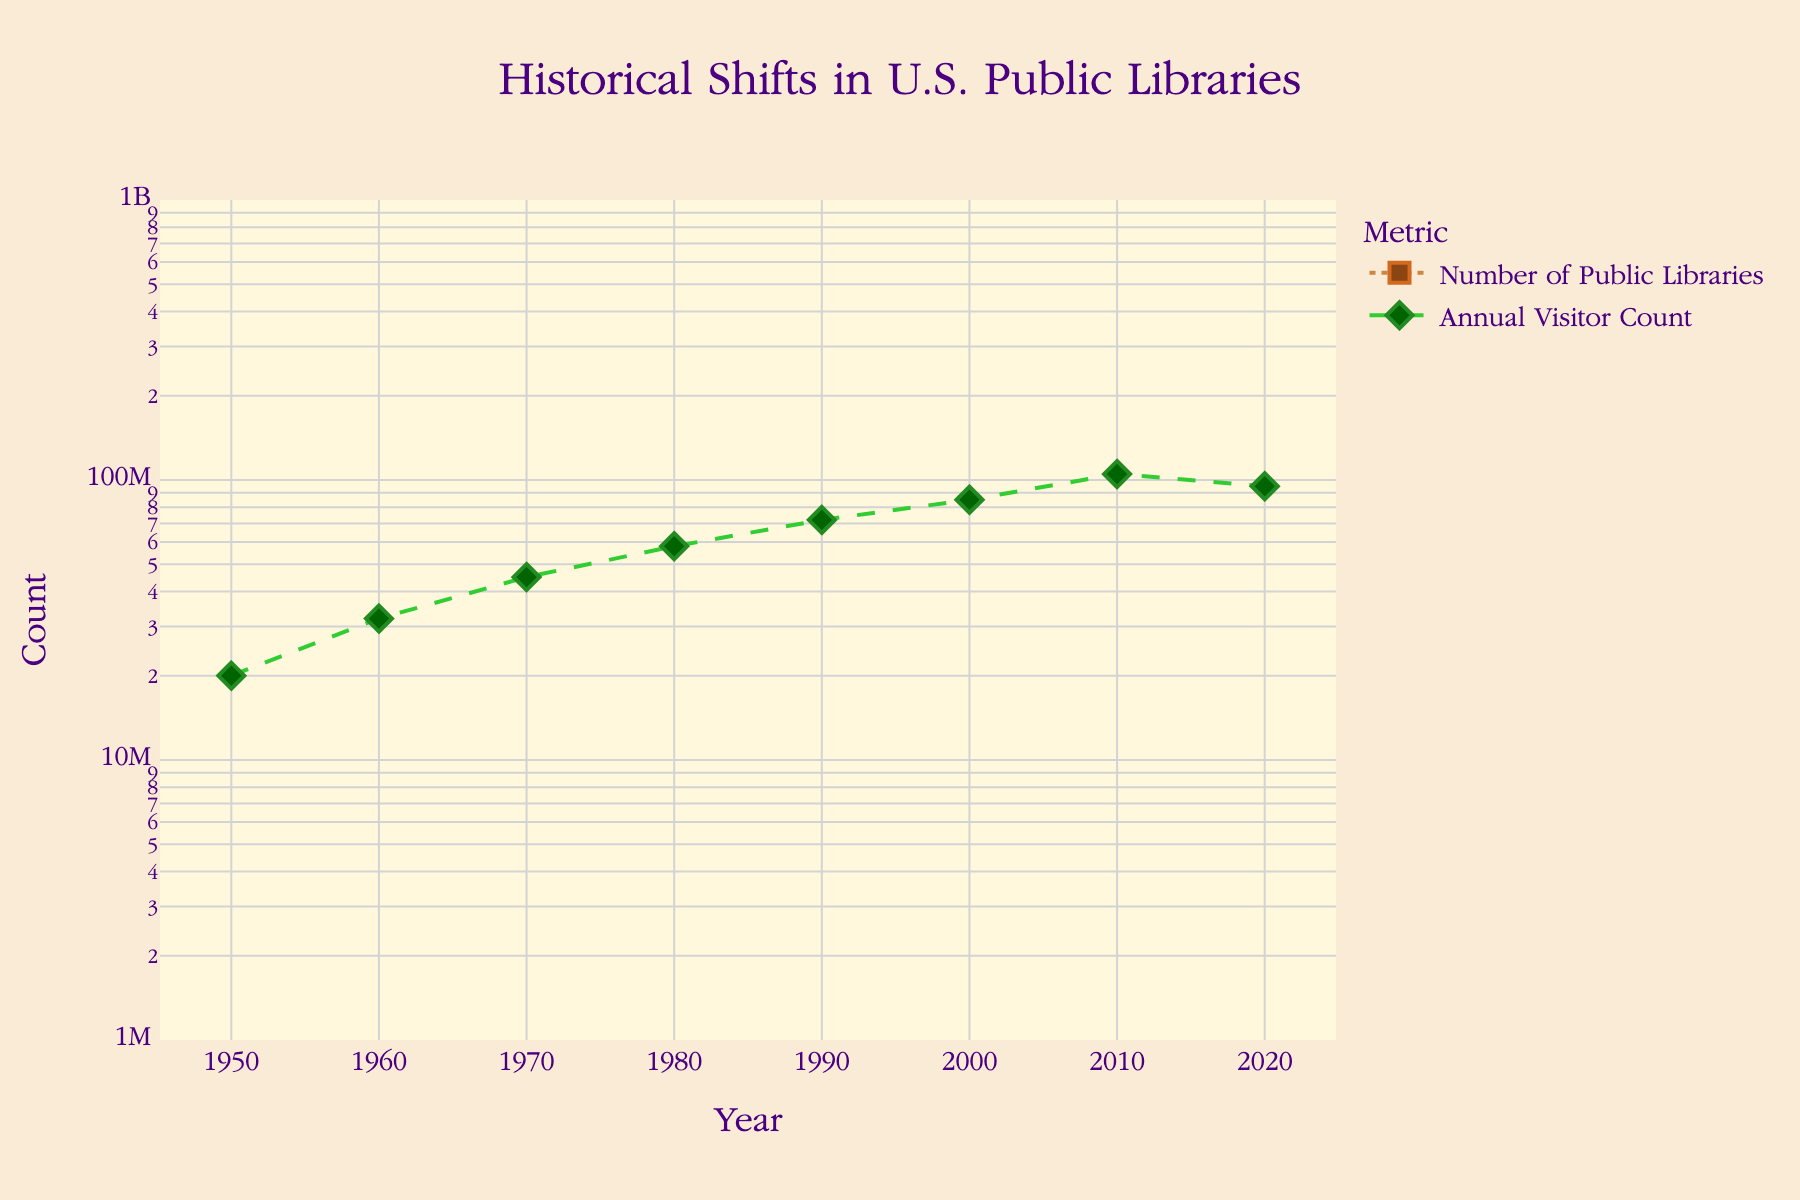what is the title of the figure? The title can be found at the top of the figure. In this case, the figure's title states the primary focus of the chart, which is "Historical Shifts in U.S. Public Libraries."
Answer: Historical Shifts in U.S. Public Libraries How many years are being displayed in the figure? Count the number of x-axis ticks labeled with years to find the number of displayed years. The years listed in the data are 1950, 1960, 1970, 1980, 1990, 2000, 2010, and 2020, thus covering a span of decades.
Answer: 8 What color represents the "Annual Visitor Count" data points? The color representing the "Annual Visitor Count" can be determined by looking at the legend of the figure. The legend shows markers and lines for each metric with distinct colors. The "Annual Visitor Count" is represented by the color green.
Answer: green Which metric has the larger data values, "Number of Public Libraries" or "Annual Visitor Count"? Compare the y-values mapped for each metric on the log scale to determine which has larger values. The "Annual Visitor Count" metric has values in the millions, while the "Number of Public Libraries" has values in thousands.
Answer: Annual Visitor Count What's the difference in the number of public libraries between the years 1950 and 2020? Identify the "Number of Public Libraries" values for the years 1950 and 2020 from the data points. Subtract the 1950 value (5,600) from the 2020 value (18,600) to find the difference.
Answer: 13,000 Did the annual visitor count increase or decrease between 2010 and 2020? Compare the "Annual Visitor Count" values for 2010 and 2020 from the data points. The value in 2010 was 105,000,000, and in 2020 it was 95,000,000. The count decreased.
Answer: decrease What is the approximate ratio of the Annual Visitor Count to the Number of Public Libraries in 2000? Determine the values for both metrics in 2000: 85,000,000 Annual Visitor Count and 14,900 Public Libraries. Divide the visitor count by the number of libraries to find the ratio (85000000/14900).
Answer: approx. 5,705 What trend do you observe in the number of public libraries from 1950 to 2020? Look at the data points for "Number of Public Libraries" over the years. From 1950 to 2020, the number continuously increases from 5,600 to 18,600. This indicates a consistent growth in the number of public libraries.
Answer: increasing trend Which year had the highest number of public libraries? Identify the year with the highest y-value for the "Number of Public Libraries" dataset. In the data provided, 2020 has the highest value of 18,600.
Answer: 2020 Is there any year where the number of libraries significantly jumped compared to the previous decade? Check the data points for "Number of Public Libraries" across each decade and identify any significant jumps. Between 1990 (12,900) and 2000 (14,900), the increase of 2,000 is notable.
Answer: 2000 